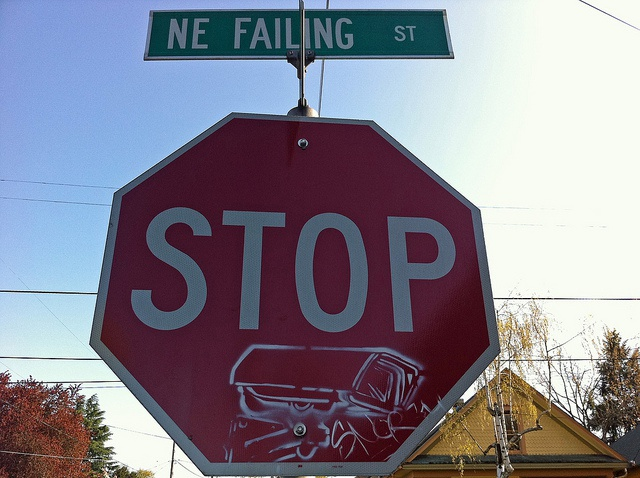Describe the objects in this image and their specific colors. I can see a stop sign in gray, purple, and black tones in this image. 